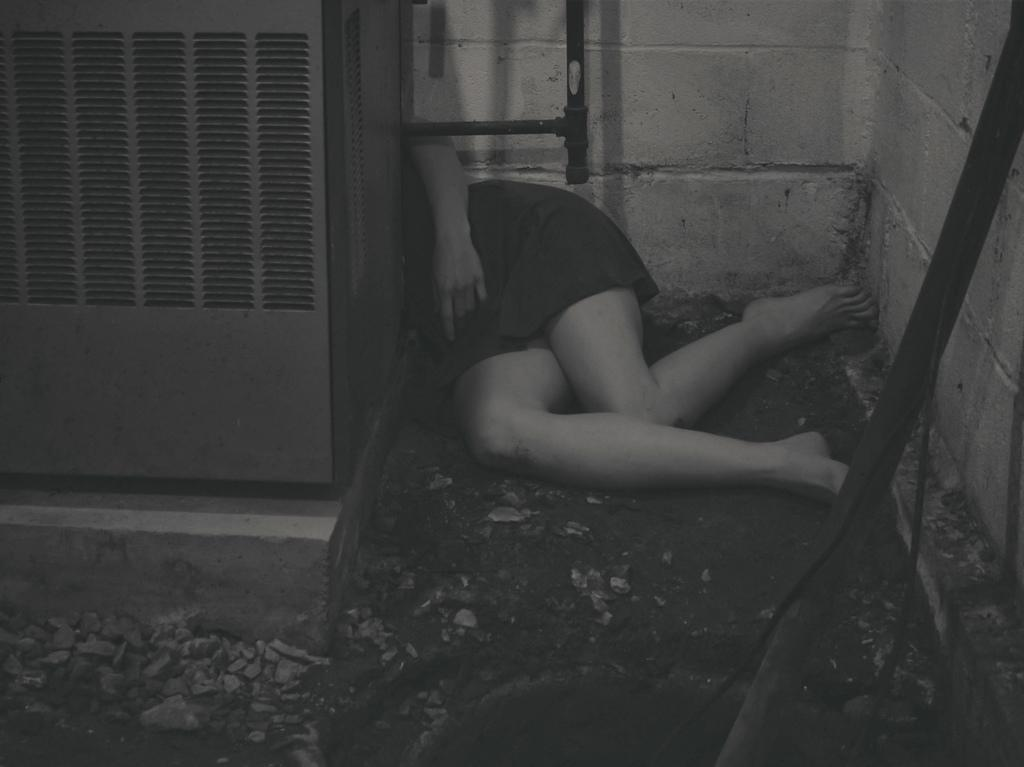Who or what is on the right side of the image? There is a person on the right side of the image. What is at the bottom of the image? There are stones at the bottom of the image. What can be seen in the background of the image? There is a wall in the background of the image. What color scheme is used in the image? The image is black and white. How many eyes can be seen on the branch in the image? There is no branch or eyes present in the image. What type of zephyr is blowing in the image? There is no zephyr present in the image; it is a black and white image with a person, stones, and a wall. 